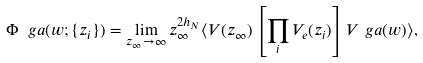<formula> <loc_0><loc_0><loc_500><loc_500>\Phi _ { \ } g a ( w ; \{ z _ { i } \} ) = \lim _ { z _ { \infty } \rightarrow \infty } z ^ { 2 h _ { N } } _ { \infty } \langle V ( z _ { \infty } ) \left [ \prod _ { i } V _ { e } ( z _ { i } ) \right ] V _ { \ } g a ( w ) \rangle ,</formula> 